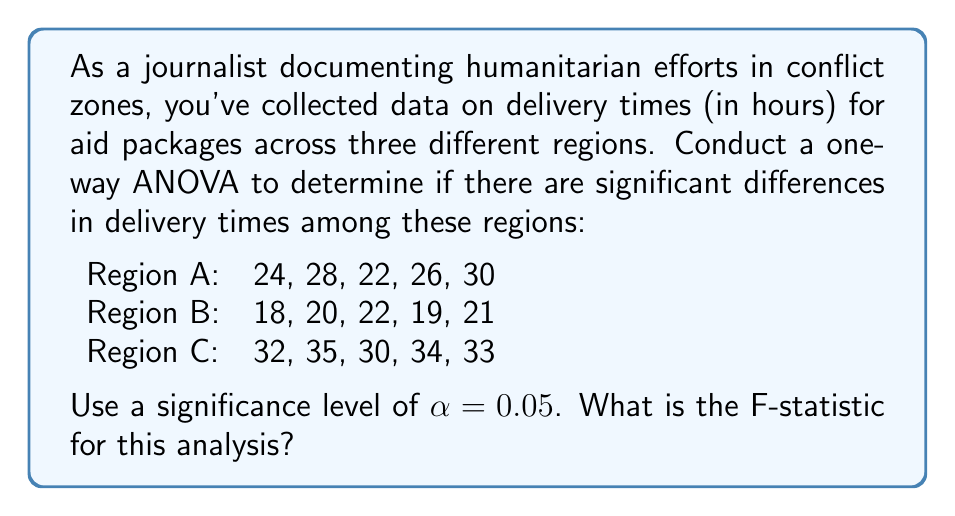Provide a solution to this math problem. To conduct a one-way ANOVA, we'll follow these steps:

1. Calculate the sum of squares between groups (SSB)
2. Calculate the sum of squares within groups (SSW)
3. Calculate the degrees of freedom (df)
4. Compute the mean squares
5. Calculate the F-statistic

Step 1: Calculate SSB

First, we need to find the grand mean and group means:

Grand mean: $\bar{X} = \frac{24+28+22+26+30+18+20+22+19+21+32+35+30+34+33}{15} = 26.27$

Group means:
$\bar{X}_A = 26$
$\bar{X}_B = 20$
$\bar{X}_C = 32.8$

Now, we can calculate SSB:

$$SSB = \sum_{i=1}^k n_i(\bar{X}_i - \bar{X})^2$$

Where $k$ is the number of groups and $n_i$ is the number of observations in each group.

$$SSB = 5(26 - 26.27)^2 + 5(20 - 26.27)^2 + 5(32.8 - 26.27)^2 = 450.13$$

Step 2: Calculate SSW

$$SSW = \sum_{i=1}^k\sum_{j=1}^{n_i} (X_{ij} - \bar{X}_i)^2$$

For Region A: $(24-26)^2 + (28-26)^2 + (22-26)^2 + (26-26)^2 + (30-26)^2 = 40$
For Region B: $(18-20)^2 + (20-20)^2 + (22-20)^2 + (19-20)^2 + (21-20)^2 = 10$
For Region C: $(32-32.8)^2 + (35-32.8)^2 + (30-32.8)^2 + (34-32.8)^2 + (33-32.8)^2 = 16.8$

$$SSW = 40 + 10 + 16.8 = 66.8$$

Step 3: Calculate degrees of freedom

$df_{between} = k - 1 = 3 - 1 = 2$
$df_{within} = N - k = 15 - 3 = 12$
Where $N$ is the total number of observations.

Step 4: Compute mean squares

$$MS_{between} = \frac{SSB}{df_{between}} = \frac{450.13}{2} = 225.065$$
$$MS_{within} = \frac{SSW}{df_{within}} = \frac{66.8}{12} = 5.567$$

Step 5: Calculate the F-statistic

$$F = \frac{MS_{between}}{MS_{within}} = \frac{225.065}{5.567} = 40.43$$
Answer: The F-statistic for this analysis is 40.43. 